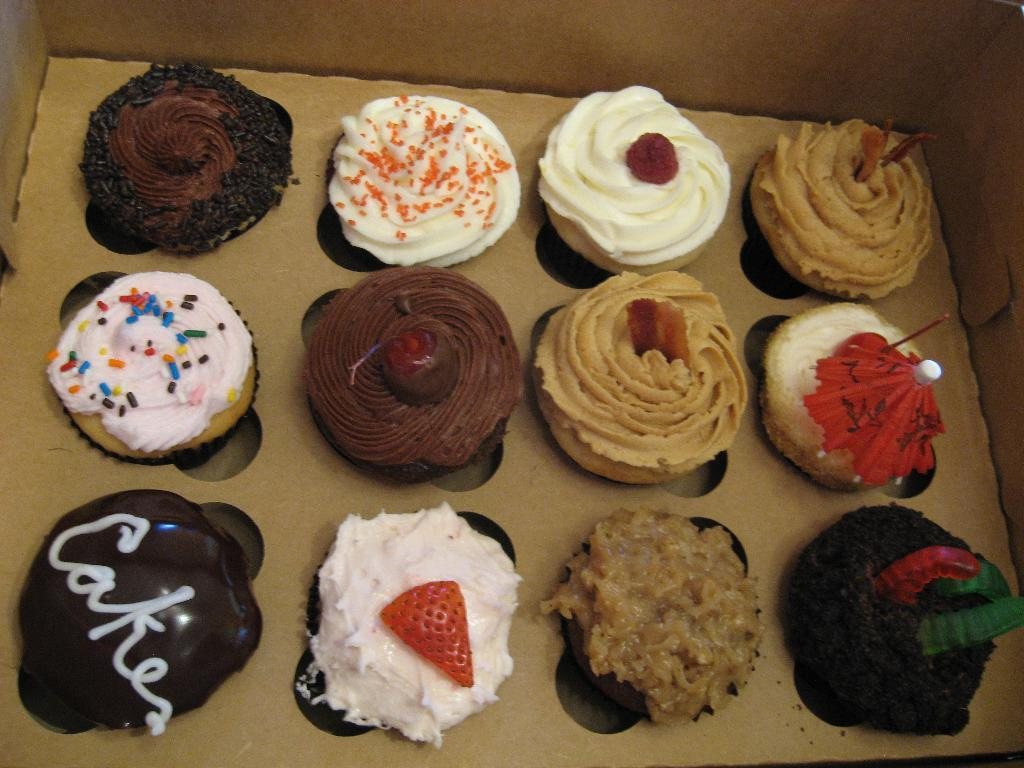What is the main subject of the image? The main subject of the image is cupcakes. Where are the cupcakes located in the image? The cupcakes are in the center of the image. What type of music can be heard playing in the background of the image? There is no music present in the image, as it features cupcakes in the center. What color is the orange in the image? There is no orange present in the image; it only contains cupcakes. 